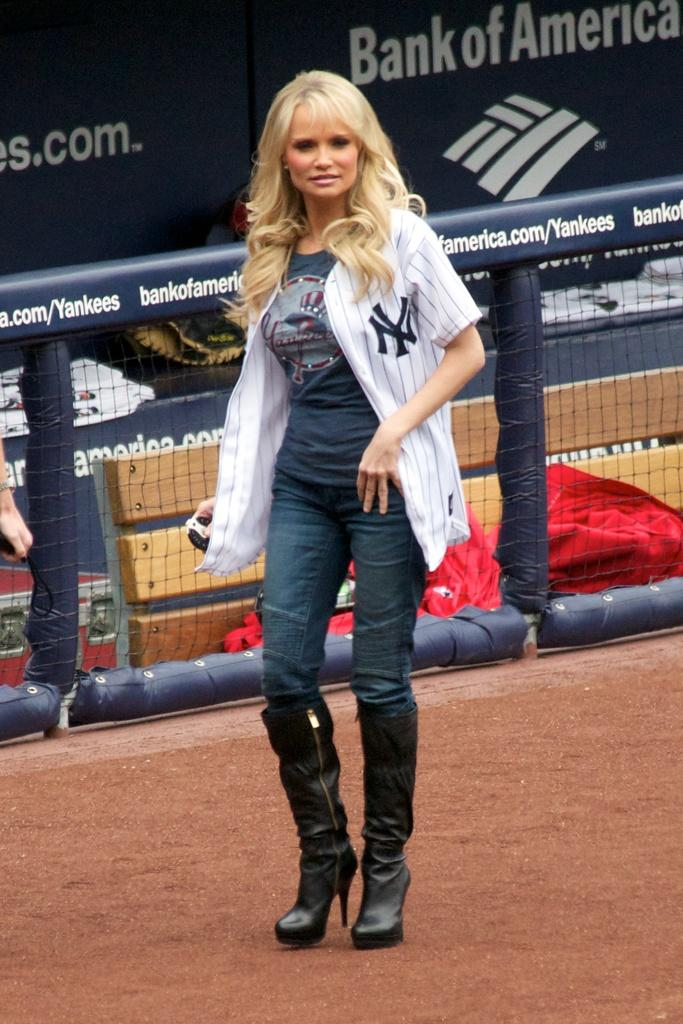<image>
Share a concise interpretation of the image provided. Women wearing a New York Yankees jersey sponsored by Bank of America. 